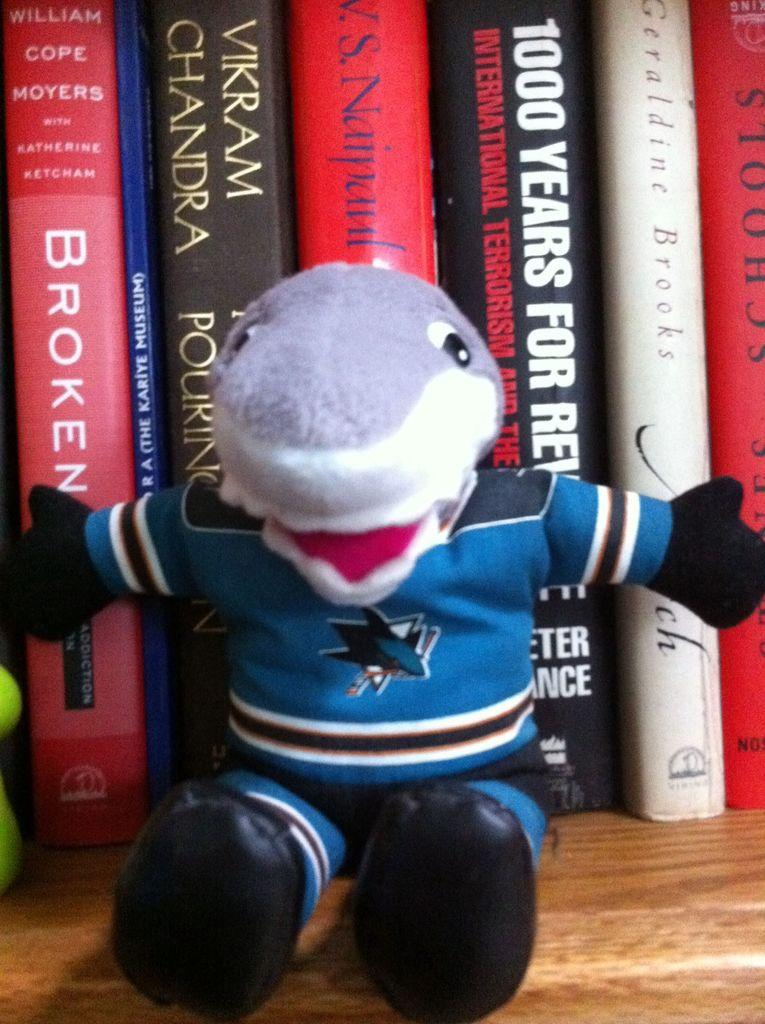<image>
Give a short and clear explanation of the subsequent image. A stuffed toy in front of some books, one of which is called Broken. 